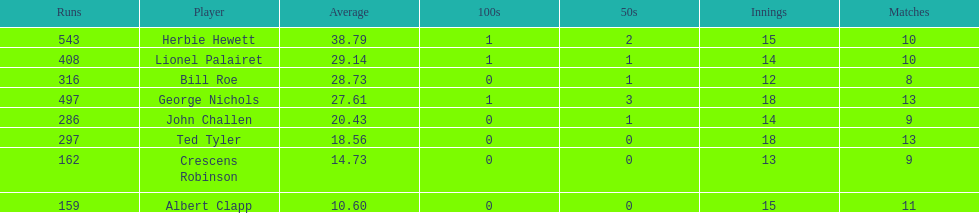How many more runs does john have than albert? 127. 